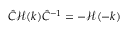<formula> <loc_0><loc_0><loc_500><loc_500>\hat { C } \mathcal { H } ( k ) \hat { C } ^ { - 1 } = - \mathcal { H } ( - k )</formula> 